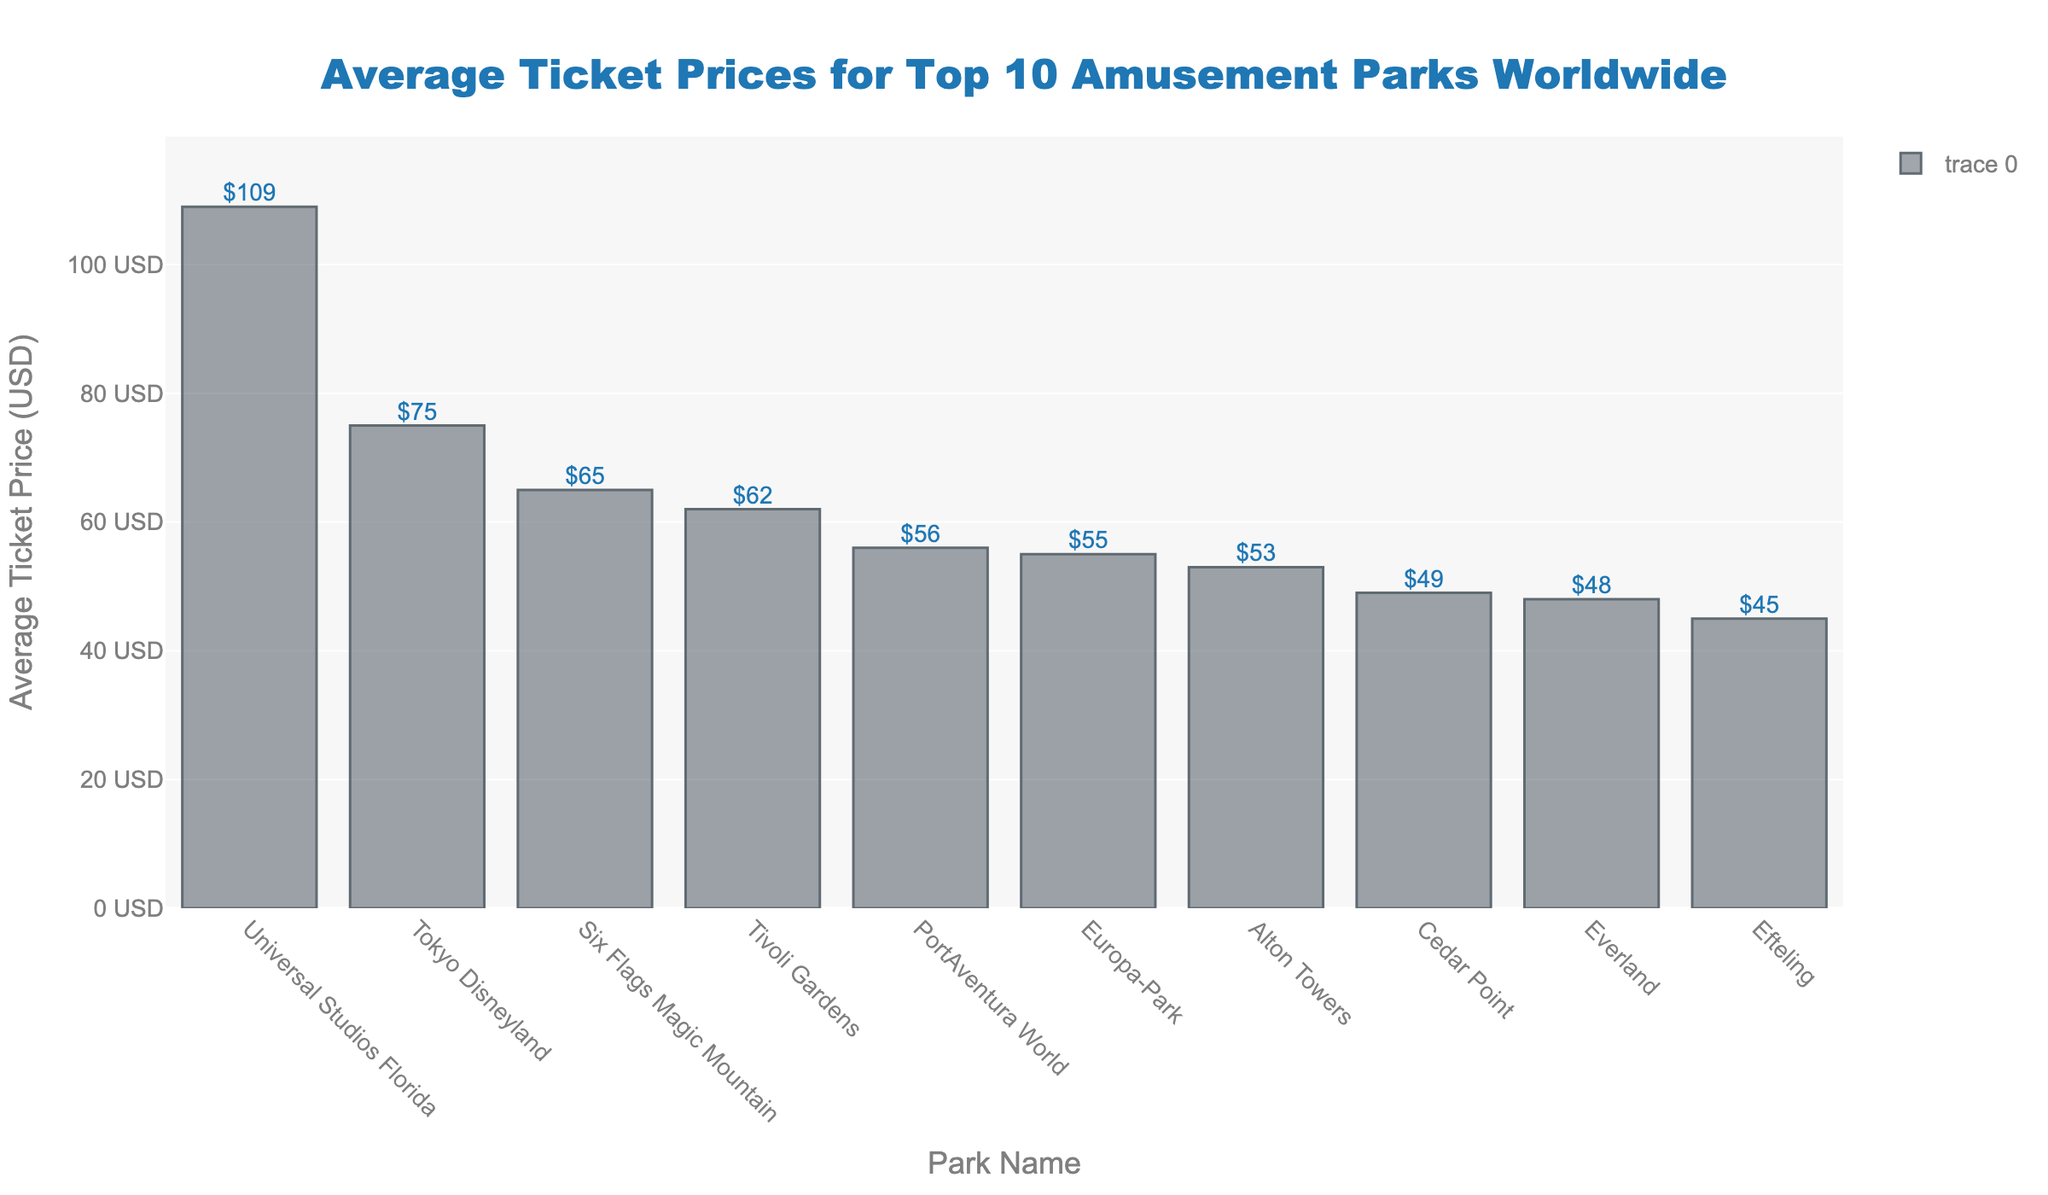Which park has the highest average ticket price? By examining the heights of the bars depicted in the chart, the tallest bar corresponds to Universal Studios Florida, thus indicating it has the highest average ticket price.
Answer: Universal Studios Florida Which park has the second-lowest average ticket price? By visually ordering the bars by height, the second shortest bar is associated with Everland, indicating it has the second-lowest average ticket price.
Answer: Everland How much more expensive is a ticket to Universal Studios Florida compared to Cedar Point? The average ticket price for Universal Studios Florida is $109, and for Cedar Point, it is $49. The difference is calculated as $109 - $49.
Answer: $60 What is the average ticket price of the top three most expensive parks? The top three most expensive parks are Universal Studios Florida ($109), Tokyo Disneyland ($75), and Six Flags Magic Mountain ($65). Calculate the average: \((109 + 75 + 65) / 3 = 249 / 3\).
Answer: $83 Which parks have an average ticket price lower than $50? By visually identifying the bars with heights corresponding to prices less than $50, Cedar Point ($49) and Everland ($48) meet the criteria. List the parks.
Answer: Cedar Point, Everland What is the combined price of tickets for Tokyo Disneyland and Alton Towers? Add the average ticket prices of Tokyo Disneyland ($75) and Alton Towers ($53): \(75 + 53 = 128\).
Answer: $128 How many parks have an average ticket price between $50 and $70? By visually inspecting the bars, the parks with ticket prices in this range are Six Flags Magic Mountain ($65), PortAventura World ($56), Alton Towers ($53), and Tivoli Gardens ($62). Count the bars.
Answer: 4 Which two parks have the closest average ticket prices, and what is their difference? By examining the bar heights, PortAventura World ($56) and Alton Towers ($53) have close prices. The difference is calculated as $56 - $53.
Answer: PortAventura World and Alton Towers, $3 What is the total average ticket price for all the parks listed in the chart? Sum the average ticket prices of all the parks: \(75 + 109 + 55 + 49 + 65 + 56 + 45 + 53 + 62 + 48 = 617\).
Answer: $617 How much cheaper is the average ticket price at Europa-Park compared to Universal Studios Florida? The average ticket price for Europa-Park is $55, and for Universal Studios Florida, it is $109. The price difference is calculated as $109 - $55.
Answer: $54 